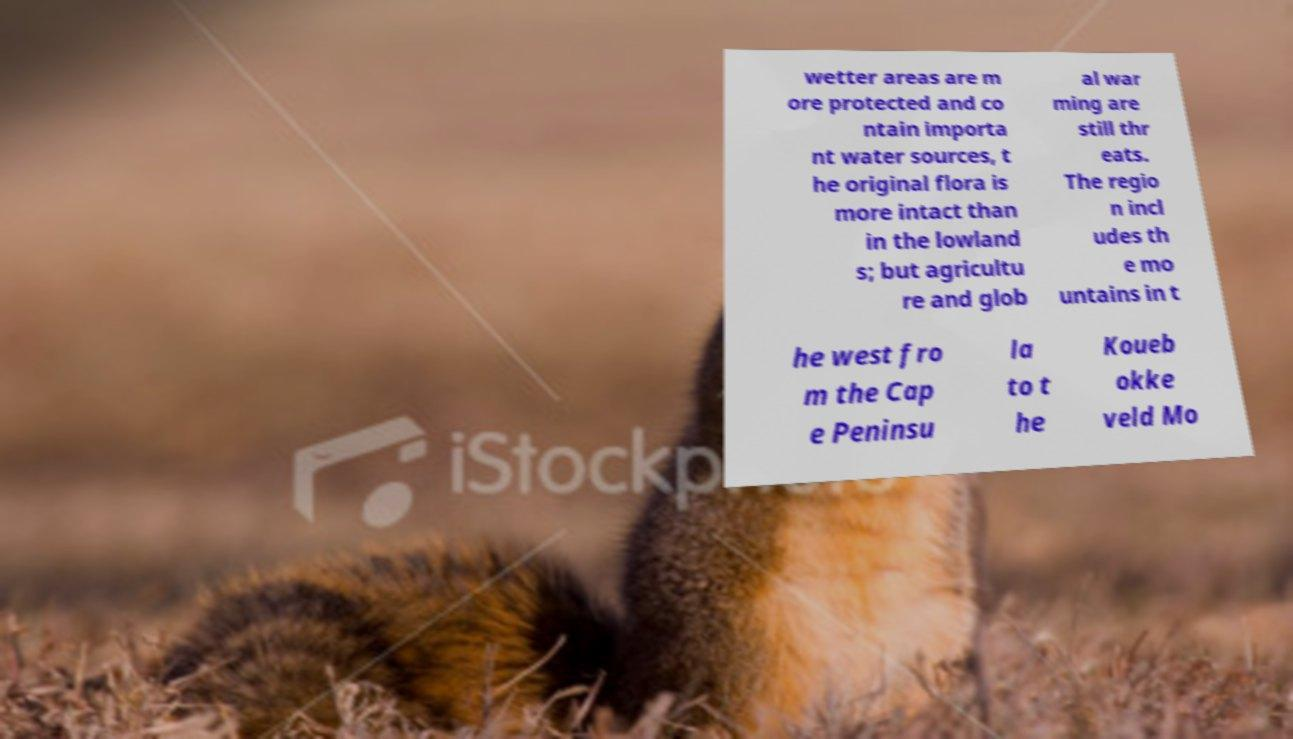Could you extract and type out the text from this image? wetter areas are m ore protected and co ntain importa nt water sources, t he original flora is more intact than in the lowland s; but agricultu re and glob al war ming are still thr eats. The regio n incl udes th e mo untains in t he west fro m the Cap e Peninsu la to t he Koueb okke veld Mo 